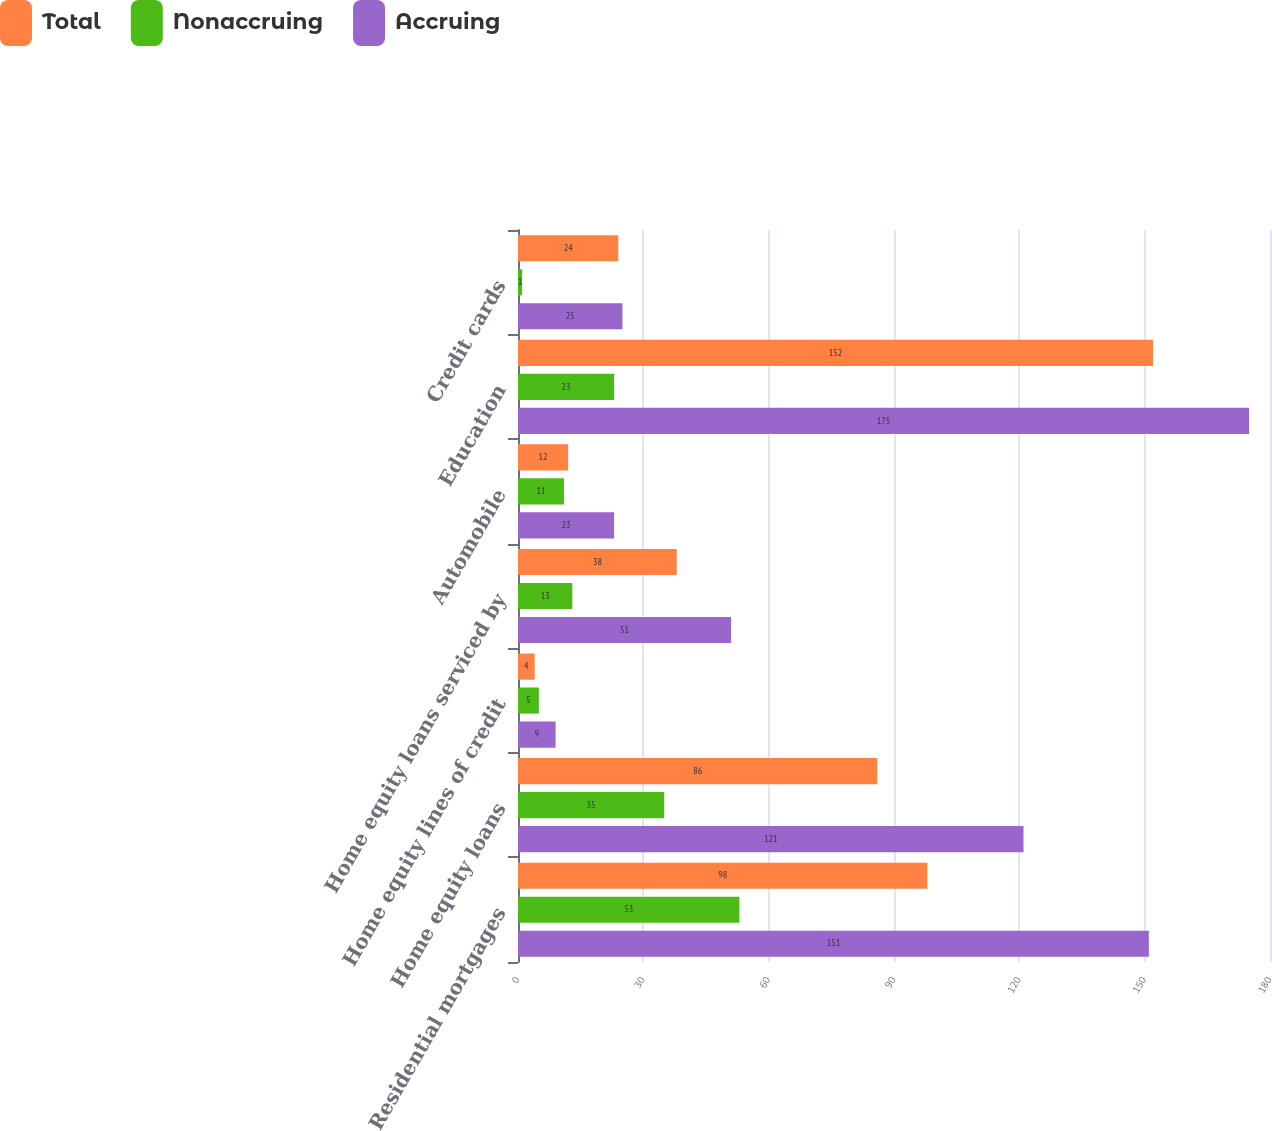Convert chart. <chart><loc_0><loc_0><loc_500><loc_500><stacked_bar_chart><ecel><fcel>Residential mortgages<fcel>Home equity loans<fcel>Home equity lines of credit<fcel>Home equity loans serviced by<fcel>Automobile<fcel>Education<fcel>Credit cards<nl><fcel>Total<fcel>98<fcel>86<fcel>4<fcel>38<fcel>12<fcel>152<fcel>24<nl><fcel>Nonaccruing<fcel>53<fcel>35<fcel>5<fcel>13<fcel>11<fcel>23<fcel>1<nl><fcel>Accruing<fcel>151<fcel>121<fcel>9<fcel>51<fcel>23<fcel>175<fcel>25<nl></chart> 